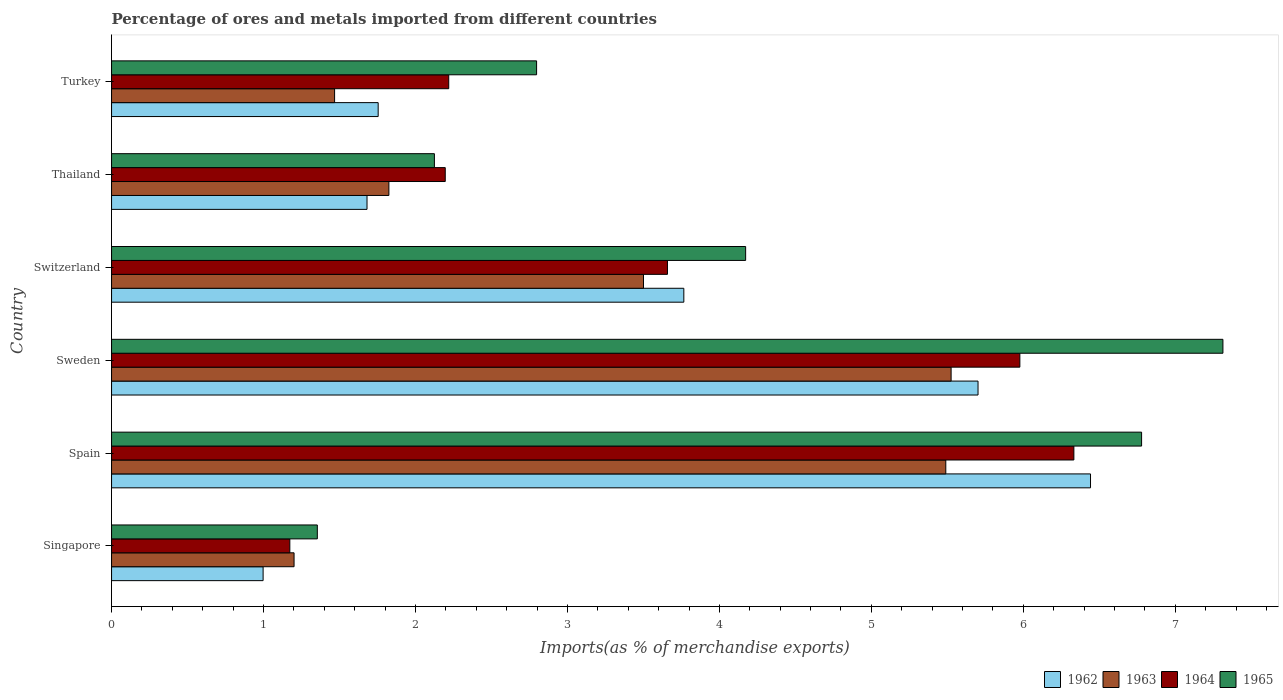Are the number of bars per tick equal to the number of legend labels?
Make the answer very short. Yes. What is the label of the 2nd group of bars from the top?
Offer a terse response. Thailand. In how many cases, is the number of bars for a given country not equal to the number of legend labels?
Provide a short and direct response. 0. What is the percentage of imports to different countries in 1963 in Sweden?
Provide a succinct answer. 5.52. Across all countries, what is the maximum percentage of imports to different countries in 1965?
Make the answer very short. 7.31. Across all countries, what is the minimum percentage of imports to different countries in 1962?
Make the answer very short. 1. In which country was the percentage of imports to different countries in 1963 maximum?
Ensure brevity in your answer.  Sweden. In which country was the percentage of imports to different countries in 1964 minimum?
Keep it short and to the point. Singapore. What is the total percentage of imports to different countries in 1963 in the graph?
Provide a short and direct response. 19.01. What is the difference between the percentage of imports to different countries in 1963 in Singapore and that in Turkey?
Give a very brief answer. -0.27. What is the difference between the percentage of imports to different countries in 1963 in Switzerland and the percentage of imports to different countries in 1962 in Spain?
Provide a short and direct response. -2.94. What is the average percentage of imports to different countries in 1965 per country?
Provide a short and direct response. 4.09. What is the difference between the percentage of imports to different countries in 1964 and percentage of imports to different countries in 1963 in Singapore?
Your answer should be compact. -0.03. What is the ratio of the percentage of imports to different countries in 1965 in Thailand to that in Turkey?
Give a very brief answer. 0.76. Is the percentage of imports to different countries in 1964 in Switzerland less than that in Thailand?
Keep it short and to the point. No. Is the difference between the percentage of imports to different countries in 1964 in Sweden and Thailand greater than the difference between the percentage of imports to different countries in 1963 in Sweden and Thailand?
Provide a short and direct response. Yes. What is the difference between the highest and the second highest percentage of imports to different countries in 1962?
Your response must be concise. 0.74. What is the difference between the highest and the lowest percentage of imports to different countries in 1962?
Ensure brevity in your answer.  5.45. In how many countries, is the percentage of imports to different countries in 1964 greater than the average percentage of imports to different countries in 1964 taken over all countries?
Make the answer very short. 3. Is the sum of the percentage of imports to different countries in 1964 in Singapore and Spain greater than the maximum percentage of imports to different countries in 1962 across all countries?
Your answer should be very brief. Yes. Is it the case that in every country, the sum of the percentage of imports to different countries in 1964 and percentage of imports to different countries in 1963 is greater than the sum of percentage of imports to different countries in 1962 and percentage of imports to different countries in 1965?
Ensure brevity in your answer.  No. What does the 1st bar from the top in Spain represents?
Your response must be concise. 1965. What does the 4th bar from the bottom in Turkey represents?
Your answer should be compact. 1965. How many bars are there?
Provide a short and direct response. 24. How many countries are there in the graph?
Provide a succinct answer. 6. What is the difference between two consecutive major ticks on the X-axis?
Offer a terse response. 1. Does the graph contain any zero values?
Offer a very short reply. No. Where does the legend appear in the graph?
Keep it short and to the point. Bottom right. How are the legend labels stacked?
Your answer should be compact. Horizontal. What is the title of the graph?
Your answer should be very brief. Percentage of ores and metals imported from different countries. Does "1972" appear as one of the legend labels in the graph?
Offer a very short reply. No. What is the label or title of the X-axis?
Your answer should be compact. Imports(as % of merchandise exports). What is the Imports(as % of merchandise exports) in 1962 in Singapore?
Offer a very short reply. 1. What is the Imports(as % of merchandise exports) in 1963 in Singapore?
Make the answer very short. 1.2. What is the Imports(as % of merchandise exports) in 1964 in Singapore?
Provide a succinct answer. 1.17. What is the Imports(as % of merchandise exports) in 1965 in Singapore?
Your answer should be very brief. 1.35. What is the Imports(as % of merchandise exports) in 1962 in Spain?
Keep it short and to the point. 6.44. What is the Imports(as % of merchandise exports) in 1963 in Spain?
Ensure brevity in your answer.  5.49. What is the Imports(as % of merchandise exports) in 1964 in Spain?
Your response must be concise. 6.33. What is the Imports(as % of merchandise exports) in 1965 in Spain?
Your answer should be very brief. 6.78. What is the Imports(as % of merchandise exports) in 1962 in Sweden?
Give a very brief answer. 5.7. What is the Imports(as % of merchandise exports) of 1963 in Sweden?
Your answer should be very brief. 5.52. What is the Imports(as % of merchandise exports) of 1964 in Sweden?
Make the answer very short. 5.98. What is the Imports(as % of merchandise exports) in 1965 in Sweden?
Ensure brevity in your answer.  7.31. What is the Imports(as % of merchandise exports) in 1962 in Switzerland?
Keep it short and to the point. 3.77. What is the Imports(as % of merchandise exports) of 1963 in Switzerland?
Your answer should be compact. 3.5. What is the Imports(as % of merchandise exports) of 1964 in Switzerland?
Offer a terse response. 3.66. What is the Imports(as % of merchandise exports) of 1965 in Switzerland?
Your response must be concise. 4.17. What is the Imports(as % of merchandise exports) of 1962 in Thailand?
Keep it short and to the point. 1.68. What is the Imports(as % of merchandise exports) in 1963 in Thailand?
Your answer should be compact. 1.83. What is the Imports(as % of merchandise exports) of 1964 in Thailand?
Make the answer very short. 2.2. What is the Imports(as % of merchandise exports) in 1965 in Thailand?
Your answer should be compact. 2.12. What is the Imports(as % of merchandise exports) in 1962 in Turkey?
Provide a short and direct response. 1.75. What is the Imports(as % of merchandise exports) of 1963 in Turkey?
Ensure brevity in your answer.  1.47. What is the Imports(as % of merchandise exports) of 1964 in Turkey?
Keep it short and to the point. 2.22. What is the Imports(as % of merchandise exports) of 1965 in Turkey?
Offer a terse response. 2.8. Across all countries, what is the maximum Imports(as % of merchandise exports) of 1962?
Provide a short and direct response. 6.44. Across all countries, what is the maximum Imports(as % of merchandise exports) in 1963?
Your response must be concise. 5.52. Across all countries, what is the maximum Imports(as % of merchandise exports) in 1964?
Your answer should be compact. 6.33. Across all countries, what is the maximum Imports(as % of merchandise exports) in 1965?
Provide a short and direct response. 7.31. Across all countries, what is the minimum Imports(as % of merchandise exports) in 1962?
Give a very brief answer. 1. Across all countries, what is the minimum Imports(as % of merchandise exports) in 1963?
Keep it short and to the point. 1.2. Across all countries, what is the minimum Imports(as % of merchandise exports) of 1964?
Your answer should be compact. 1.17. Across all countries, what is the minimum Imports(as % of merchandise exports) in 1965?
Keep it short and to the point. 1.35. What is the total Imports(as % of merchandise exports) of 1962 in the graph?
Offer a very short reply. 20.34. What is the total Imports(as % of merchandise exports) of 1963 in the graph?
Provide a succinct answer. 19.01. What is the total Imports(as % of merchandise exports) of 1964 in the graph?
Your answer should be compact. 21.56. What is the total Imports(as % of merchandise exports) of 1965 in the graph?
Ensure brevity in your answer.  24.54. What is the difference between the Imports(as % of merchandise exports) in 1962 in Singapore and that in Spain?
Offer a very short reply. -5.45. What is the difference between the Imports(as % of merchandise exports) of 1963 in Singapore and that in Spain?
Offer a very short reply. -4.29. What is the difference between the Imports(as % of merchandise exports) in 1964 in Singapore and that in Spain?
Make the answer very short. -5.16. What is the difference between the Imports(as % of merchandise exports) of 1965 in Singapore and that in Spain?
Your response must be concise. -5.42. What is the difference between the Imports(as % of merchandise exports) in 1962 in Singapore and that in Sweden?
Offer a terse response. -4.7. What is the difference between the Imports(as % of merchandise exports) of 1963 in Singapore and that in Sweden?
Give a very brief answer. -4.32. What is the difference between the Imports(as % of merchandise exports) in 1964 in Singapore and that in Sweden?
Keep it short and to the point. -4.8. What is the difference between the Imports(as % of merchandise exports) in 1965 in Singapore and that in Sweden?
Provide a succinct answer. -5.96. What is the difference between the Imports(as % of merchandise exports) of 1962 in Singapore and that in Switzerland?
Offer a very short reply. -2.77. What is the difference between the Imports(as % of merchandise exports) of 1963 in Singapore and that in Switzerland?
Offer a very short reply. -2.3. What is the difference between the Imports(as % of merchandise exports) in 1964 in Singapore and that in Switzerland?
Your answer should be compact. -2.49. What is the difference between the Imports(as % of merchandise exports) of 1965 in Singapore and that in Switzerland?
Your response must be concise. -2.82. What is the difference between the Imports(as % of merchandise exports) of 1962 in Singapore and that in Thailand?
Your response must be concise. -0.68. What is the difference between the Imports(as % of merchandise exports) in 1963 in Singapore and that in Thailand?
Provide a short and direct response. -0.62. What is the difference between the Imports(as % of merchandise exports) of 1964 in Singapore and that in Thailand?
Your response must be concise. -1.02. What is the difference between the Imports(as % of merchandise exports) in 1965 in Singapore and that in Thailand?
Your answer should be very brief. -0.77. What is the difference between the Imports(as % of merchandise exports) in 1962 in Singapore and that in Turkey?
Provide a succinct answer. -0.76. What is the difference between the Imports(as % of merchandise exports) of 1963 in Singapore and that in Turkey?
Provide a short and direct response. -0.27. What is the difference between the Imports(as % of merchandise exports) of 1964 in Singapore and that in Turkey?
Provide a short and direct response. -1.05. What is the difference between the Imports(as % of merchandise exports) of 1965 in Singapore and that in Turkey?
Ensure brevity in your answer.  -1.44. What is the difference between the Imports(as % of merchandise exports) in 1962 in Spain and that in Sweden?
Your answer should be compact. 0.74. What is the difference between the Imports(as % of merchandise exports) of 1963 in Spain and that in Sweden?
Offer a very short reply. -0.04. What is the difference between the Imports(as % of merchandise exports) in 1964 in Spain and that in Sweden?
Offer a very short reply. 0.36. What is the difference between the Imports(as % of merchandise exports) in 1965 in Spain and that in Sweden?
Ensure brevity in your answer.  -0.54. What is the difference between the Imports(as % of merchandise exports) in 1962 in Spain and that in Switzerland?
Make the answer very short. 2.68. What is the difference between the Imports(as % of merchandise exports) of 1963 in Spain and that in Switzerland?
Give a very brief answer. 1.99. What is the difference between the Imports(as % of merchandise exports) of 1964 in Spain and that in Switzerland?
Keep it short and to the point. 2.67. What is the difference between the Imports(as % of merchandise exports) of 1965 in Spain and that in Switzerland?
Your answer should be compact. 2.61. What is the difference between the Imports(as % of merchandise exports) in 1962 in Spain and that in Thailand?
Keep it short and to the point. 4.76. What is the difference between the Imports(as % of merchandise exports) of 1963 in Spain and that in Thailand?
Keep it short and to the point. 3.66. What is the difference between the Imports(as % of merchandise exports) of 1964 in Spain and that in Thailand?
Give a very brief answer. 4.14. What is the difference between the Imports(as % of merchandise exports) in 1965 in Spain and that in Thailand?
Offer a terse response. 4.65. What is the difference between the Imports(as % of merchandise exports) of 1962 in Spain and that in Turkey?
Provide a succinct answer. 4.69. What is the difference between the Imports(as % of merchandise exports) of 1963 in Spain and that in Turkey?
Offer a very short reply. 4.02. What is the difference between the Imports(as % of merchandise exports) in 1964 in Spain and that in Turkey?
Offer a very short reply. 4.11. What is the difference between the Imports(as % of merchandise exports) of 1965 in Spain and that in Turkey?
Ensure brevity in your answer.  3.98. What is the difference between the Imports(as % of merchandise exports) in 1962 in Sweden and that in Switzerland?
Give a very brief answer. 1.94. What is the difference between the Imports(as % of merchandise exports) in 1963 in Sweden and that in Switzerland?
Your answer should be very brief. 2.02. What is the difference between the Imports(as % of merchandise exports) in 1964 in Sweden and that in Switzerland?
Provide a succinct answer. 2.32. What is the difference between the Imports(as % of merchandise exports) in 1965 in Sweden and that in Switzerland?
Offer a very short reply. 3.14. What is the difference between the Imports(as % of merchandise exports) in 1962 in Sweden and that in Thailand?
Keep it short and to the point. 4.02. What is the difference between the Imports(as % of merchandise exports) of 1963 in Sweden and that in Thailand?
Ensure brevity in your answer.  3.7. What is the difference between the Imports(as % of merchandise exports) of 1964 in Sweden and that in Thailand?
Ensure brevity in your answer.  3.78. What is the difference between the Imports(as % of merchandise exports) in 1965 in Sweden and that in Thailand?
Make the answer very short. 5.19. What is the difference between the Imports(as % of merchandise exports) in 1962 in Sweden and that in Turkey?
Make the answer very short. 3.95. What is the difference between the Imports(as % of merchandise exports) of 1963 in Sweden and that in Turkey?
Your response must be concise. 4.06. What is the difference between the Imports(as % of merchandise exports) in 1964 in Sweden and that in Turkey?
Provide a short and direct response. 3.76. What is the difference between the Imports(as % of merchandise exports) of 1965 in Sweden and that in Turkey?
Your answer should be compact. 4.52. What is the difference between the Imports(as % of merchandise exports) in 1962 in Switzerland and that in Thailand?
Your answer should be compact. 2.08. What is the difference between the Imports(as % of merchandise exports) of 1963 in Switzerland and that in Thailand?
Make the answer very short. 1.68. What is the difference between the Imports(as % of merchandise exports) in 1964 in Switzerland and that in Thailand?
Offer a terse response. 1.46. What is the difference between the Imports(as % of merchandise exports) in 1965 in Switzerland and that in Thailand?
Offer a terse response. 2.05. What is the difference between the Imports(as % of merchandise exports) in 1962 in Switzerland and that in Turkey?
Offer a very short reply. 2.01. What is the difference between the Imports(as % of merchandise exports) of 1963 in Switzerland and that in Turkey?
Your answer should be compact. 2.03. What is the difference between the Imports(as % of merchandise exports) in 1964 in Switzerland and that in Turkey?
Your answer should be very brief. 1.44. What is the difference between the Imports(as % of merchandise exports) of 1965 in Switzerland and that in Turkey?
Keep it short and to the point. 1.38. What is the difference between the Imports(as % of merchandise exports) of 1962 in Thailand and that in Turkey?
Offer a very short reply. -0.07. What is the difference between the Imports(as % of merchandise exports) of 1963 in Thailand and that in Turkey?
Offer a terse response. 0.36. What is the difference between the Imports(as % of merchandise exports) in 1964 in Thailand and that in Turkey?
Give a very brief answer. -0.02. What is the difference between the Imports(as % of merchandise exports) of 1965 in Thailand and that in Turkey?
Make the answer very short. -0.67. What is the difference between the Imports(as % of merchandise exports) in 1962 in Singapore and the Imports(as % of merchandise exports) in 1963 in Spain?
Keep it short and to the point. -4.49. What is the difference between the Imports(as % of merchandise exports) in 1962 in Singapore and the Imports(as % of merchandise exports) in 1964 in Spain?
Your response must be concise. -5.34. What is the difference between the Imports(as % of merchandise exports) in 1962 in Singapore and the Imports(as % of merchandise exports) in 1965 in Spain?
Offer a terse response. -5.78. What is the difference between the Imports(as % of merchandise exports) of 1963 in Singapore and the Imports(as % of merchandise exports) of 1964 in Spain?
Offer a terse response. -5.13. What is the difference between the Imports(as % of merchandise exports) of 1963 in Singapore and the Imports(as % of merchandise exports) of 1965 in Spain?
Provide a short and direct response. -5.58. What is the difference between the Imports(as % of merchandise exports) of 1964 in Singapore and the Imports(as % of merchandise exports) of 1965 in Spain?
Make the answer very short. -5.61. What is the difference between the Imports(as % of merchandise exports) in 1962 in Singapore and the Imports(as % of merchandise exports) in 1963 in Sweden?
Offer a terse response. -4.53. What is the difference between the Imports(as % of merchandise exports) of 1962 in Singapore and the Imports(as % of merchandise exports) of 1964 in Sweden?
Make the answer very short. -4.98. What is the difference between the Imports(as % of merchandise exports) in 1962 in Singapore and the Imports(as % of merchandise exports) in 1965 in Sweden?
Your answer should be compact. -6.32. What is the difference between the Imports(as % of merchandise exports) in 1963 in Singapore and the Imports(as % of merchandise exports) in 1964 in Sweden?
Provide a succinct answer. -4.78. What is the difference between the Imports(as % of merchandise exports) in 1963 in Singapore and the Imports(as % of merchandise exports) in 1965 in Sweden?
Your answer should be compact. -6.11. What is the difference between the Imports(as % of merchandise exports) of 1964 in Singapore and the Imports(as % of merchandise exports) of 1965 in Sweden?
Provide a succinct answer. -6.14. What is the difference between the Imports(as % of merchandise exports) of 1962 in Singapore and the Imports(as % of merchandise exports) of 1963 in Switzerland?
Keep it short and to the point. -2.5. What is the difference between the Imports(as % of merchandise exports) in 1962 in Singapore and the Imports(as % of merchandise exports) in 1964 in Switzerland?
Your answer should be compact. -2.66. What is the difference between the Imports(as % of merchandise exports) in 1962 in Singapore and the Imports(as % of merchandise exports) in 1965 in Switzerland?
Make the answer very short. -3.18. What is the difference between the Imports(as % of merchandise exports) in 1963 in Singapore and the Imports(as % of merchandise exports) in 1964 in Switzerland?
Provide a succinct answer. -2.46. What is the difference between the Imports(as % of merchandise exports) in 1963 in Singapore and the Imports(as % of merchandise exports) in 1965 in Switzerland?
Provide a succinct answer. -2.97. What is the difference between the Imports(as % of merchandise exports) of 1964 in Singapore and the Imports(as % of merchandise exports) of 1965 in Switzerland?
Your response must be concise. -3. What is the difference between the Imports(as % of merchandise exports) of 1962 in Singapore and the Imports(as % of merchandise exports) of 1963 in Thailand?
Your response must be concise. -0.83. What is the difference between the Imports(as % of merchandise exports) of 1962 in Singapore and the Imports(as % of merchandise exports) of 1964 in Thailand?
Give a very brief answer. -1.2. What is the difference between the Imports(as % of merchandise exports) in 1962 in Singapore and the Imports(as % of merchandise exports) in 1965 in Thailand?
Your answer should be very brief. -1.13. What is the difference between the Imports(as % of merchandise exports) in 1963 in Singapore and the Imports(as % of merchandise exports) in 1964 in Thailand?
Offer a very short reply. -0.99. What is the difference between the Imports(as % of merchandise exports) in 1963 in Singapore and the Imports(as % of merchandise exports) in 1965 in Thailand?
Your answer should be very brief. -0.92. What is the difference between the Imports(as % of merchandise exports) of 1964 in Singapore and the Imports(as % of merchandise exports) of 1965 in Thailand?
Offer a very short reply. -0.95. What is the difference between the Imports(as % of merchandise exports) of 1962 in Singapore and the Imports(as % of merchandise exports) of 1963 in Turkey?
Provide a succinct answer. -0.47. What is the difference between the Imports(as % of merchandise exports) of 1962 in Singapore and the Imports(as % of merchandise exports) of 1964 in Turkey?
Ensure brevity in your answer.  -1.22. What is the difference between the Imports(as % of merchandise exports) in 1962 in Singapore and the Imports(as % of merchandise exports) in 1965 in Turkey?
Provide a short and direct response. -1.8. What is the difference between the Imports(as % of merchandise exports) of 1963 in Singapore and the Imports(as % of merchandise exports) of 1964 in Turkey?
Offer a terse response. -1.02. What is the difference between the Imports(as % of merchandise exports) of 1963 in Singapore and the Imports(as % of merchandise exports) of 1965 in Turkey?
Provide a succinct answer. -1.6. What is the difference between the Imports(as % of merchandise exports) of 1964 in Singapore and the Imports(as % of merchandise exports) of 1965 in Turkey?
Offer a very short reply. -1.62. What is the difference between the Imports(as % of merchandise exports) of 1962 in Spain and the Imports(as % of merchandise exports) of 1963 in Sweden?
Provide a short and direct response. 0.92. What is the difference between the Imports(as % of merchandise exports) of 1962 in Spain and the Imports(as % of merchandise exports) of 1964 in Sweden?
Provide a succinct answer. 0.47. What is the difference between the Imports(as % of merchandise exports) of 1962 in Spain and the Imports(as % of merchandise exports) of 1965 in Sweden?
Keep it short and to the point. -0.87. What is the difference between the Imports(as % of merchandise exports) of 1963 in Spain and the Imports(as % of merchandise exports) of 1964 in Sweden?
Keep it short and to the point. -0.49. What is the difference between the Imports(as % of merchandise exports) in 1963 in Spain and the Imports(as % of merchandise exports) in 1965 in Sweden?
Your answer should be very brief. -1.82. What is the difference between the Imports(as % of merchandise exports) of 1964 in Spain and the Imports(as % of merchandise exports) of 1965 in Sweden?
Keep it short and to the point. -0.98. What is the difference between the Imports(as % of merchandise exports) of 1962 in Spain and the Imports(as % of merchandise exports) of 1963 in Switzerland?
Your response must be concise. 2.94. What is the difference between the Imports(as % of merchandise exports) of 1962 in Spain and the Imports(as % of merchandise exports) of 1964 in Switzerland?
Keep it short and to the point. 2.78. What is the difference between the Imports(as % of merchandise exports) of 1962 in Spain and the Imports(as % of merchandise exports) of 1965 in Switzerland?
Make the answer very short. 2.27. What is the difference between the Imports(as % of merchandise exports) in 1963 in Spain and the Imports(as % of merchandise exports) in 1964 in Switzerland?
Provide a succinct answer. 1.83. What is the difference between the Imports(as % of merchandise exports) of 1963 in Spain and the Imports(as % of merchandise exports) of 1965 in Switzerland?
Make the answer very short. 1.32. What is the difference between the Imports(as % of merchandise exports) of 1964 in Spain and the Imports(as % of merchandise exports) of 1965 in Switzerland?
Make the answer very short. 2.16. What is the difference between the Imports(as % of merchandise exports) of 1962 in Spain and the Imports(as % of merchandise exports) of 1963 in Thailand?
Offer a very short reply. 4.62. What is the difference between the Imports(as % of merchandise exports) of 1962 in Spain and the Imports(as % of merchandise exports) of 1964 in Thailand?
Your response must be concise. 4.25. What is the difference between the Imports(as % of merchandise exports) of 1962 in Spain and the Imports(as % of merchandise exports) of 1965 in Thailand?
Offer a very short reply. 4.32. What is the difference between the Imports(as % of merchandise exports) in 1963 in Spain and the Imports(as % of merchandise exports) in 1964 in Thailand?
Offer a terse response. 3.29. What is the difference between the Imports(as % of merchandise exports) in 1963 in Spain and the Imports(as % of merchandise exports) in 1965 in Thailand?
Keep it short and to the point. 3.37. What is the difference between the Imports(as % of merchandise exports) of 1964 in Spain and the Imports(as % of merchandise exports) of 1965 in Thailand?
Offer a terse response. 4.21. What is the difference between the Imports(as % of merchandise exports) in 1962 in Spain and the Imports(as % of merchandise exports) in 1963 in Turkey?
Provide a short and direct response. 4.97. What is the difference between the Imports(as % of merchandise exports) in 1962 in Spain and the Imports(as % of merchandise exports) in 1964 in Turkey?
Offer a terse response. 4.22. What is the difference between the Imports(as % of merchandise exports) in 1962 in Spain and the Imports(as % of merchandise exports) in 1965 in Turkey?
Provide a succinct answer. 3.65. What is the difference between the Imports(as % of merchandise exports) of 1963 in Spain and the Imports(as % of merchandise exports) of 1964 in Turkey?
Provide a succinct answer. 3.27. What is the difference between the Imports(as % of merchandise exports) in 1963 in Spain and the Imports(as % of merchandise exports) in 1965 in Turkey?
Offer a terse response. 2.69. What is the difference between the Imports(as % of merchandise exports) of 1964 in Spain and the Imports(as % of merchandise exports) of 1965 in Turkey?
Your response must be concise. 3.54. What is the difference between the Imports(as % of merchandise exports) in 1962 in Sweden and the Imports(as % of merchandise exports) in 1963 in Switzerland?
Make the answer very short. 2.2. What is the difference between the Imports(as % of merchandise exports) in 1962 in Sweden and the Imports(as % of merchandise exports) in 1964 in Switzerland?
Give a very brief answer. 2.04. What is the difference between the Imports(as % of merchandise exports) of 1962 in Sweden and the Imports(as % of merchandise exports) of 1965 in Switzerland?
Ensure brevity in your answer.  1.53. What is the difference between the Imports(as % of merchandise exports) in 1963 in Sweden and the Imports(as % of merchandise exports) in 1964 in Switzerland?
Offer a terse response. 1.87. What is the difference between the Imports(as % of merchandise exports) of 1963 in Sweden and the Imports(as % of merchandise exports) of 1965 in Switzerland?
Offer a terse response. 1.35. What is the difference between the Imports(as % of merchandise exports) of 1964 in Sweden and the Imports(as % of merchandise exports) of 1965 in Switzerland?
Provide a short and direct response. 1.8. What is the difference between the Imports(as % of merchandise exports) of 1962 in Sweden and the Imports(as % of merchandise exports) of 1963 in Thailand?
Provide a succinct answer. 3.88. What is the difference between the Imports(as % of merchandise exports) in 1962 in Sweden and the Imports(as % of merchandise exports) in 1964 in Thailand?
Ensure brevity in your answer.  3.51. What is the difference between the Imports(as % of merchandise exports) in 1962 in Sweden and the Imports(as % of merchandise exports) in 1965 in Thailand?
Your answer should be compact. 3.58. What is the difference between the Imports(as % of merchandise exports) of 1963 in Sweden and the Imports(as % of merchandise exports) of 1964 in Thailand?
Make the answer very short. 3.33. What is the difference between the Imports(as % of merchandise exports) of 1963 in Sweden and the Imports(as % of merchandise exports) of 1965 in Thailand?
Offer a terse response. 3.4. What is the difference between the Imports(as % of merchandise exports) of 1964 in Sweden and the Imports(as % of merchandise exports) of 1965 in Thailand?
Provide a short and direct response. 3.85. What is the difference between the Imports(as % of merchandise exports) in 1962 in Sweden and the Imports(as % of merchandise exports) in 1963 in Turkey?
Offer a very short reply. 4.23. What is the difference between the Imports(as % of merchandise exports) in 1962 in Sweden and the Imports(as % of merchandise exports) in 1964 in Turkey?
Keep it short and to the point. 3.48. What is the difference between the Imports(as % of merchandise exports) in 1962 in Sweden and the Imports(as % of merchandise exports) in 1965 in Turkey?
Make the answer very short. 2.9. What is the difference between the Imports(as % of merchandise exports) of 1963 in Sweden and the Imports(as % of merchandise exports) of 1964 in Turkey?
Ensure brevity in your answer.  3.31. What is the difference between the Imports(as % of merchandise exports) of 1963 in Sweden and the Imports(as % of merchandise exports) of 1965 in Turkey?
Provide a short and direct response. 2.73. What is the difference between the Imports(as % of merchandise exports) in 1964 in Sweden and the Imports(as % of merchandise exports) in 1965 in Turkey?
Provide a succinct answer. 3.18. What is the difference between the Imports(as % of merchandise exports) of 1962 in Switzerland and the Imports(as % of merchandise exports) of 1963 in Thailand?
Provide a short and direct response. 1.94. What is the difference between the Imports(as % of merchandise exports) in 1962 in Switzerland and the Imports(as % of merchandise exports) in 1964 in Thailand?
Your response must be concise. 1.57. What is the difference between the Imports(as % of merchandise exports) in 1962 in Switzerland and the Imports(as % of merchandise exports) in 1965 in Thailand?
Provide a short and direct response. 1.64. What is the difference between the Imports(as % of merchandise exports) of 1963 in Switzerland and the Imports(as % of merchandise exports) of 1964 in Thailand?
Keep it short and to the point. 1.3. What is the difference between the Imports(as % of merchandise exports) of 1963 in Switzerland and the Imports(as % of merchandise exports) of 1965 in Thailand?
Keep it short and to the point. 1.38. What is the difference between the Imports(as % of merchandise exports) of 1964 in Switzerland and the Imports(as % of merchandise exports) of 1965 in Thailand?
Your response must be concise. 1.53. What is the difference between the Imports(as % of merchandise exports) of 1962 in Switzerland and the Imports(as % of merchandise exports) of 1963 in Turkey?
Give a very brief answer. 2.3. What is the difference between the Imports(as % of merchandise exports) in 1962 in Switzerland and the Imports(as % of merchandise exports) in 1964 in Turkey?
Keep it short and to the point. 1.55. What is the difference between the Imports(as % of merchandise exports) in 1962 in Switzerland and the Imports(as % of merchandise exports) in 1965 in Turkey?
Offer a terse response. 0.97. What is the difference between the Imports(as % of merchandise exports) in 1963 in Switzerland and the Imports(as % of merchandise exports) in 1964 in Turkey?
Your answer should be very brief. 1.28. What is the difference between the Imports(as % of merchandise exports) of 1963 in Switzerland and the Imports(as % of merchandise exports) of 1965 in Turkey?
Offer a very short reply. 0.7. What is the difference between the Imports(as % of merchandise exports) of 1964 in Switzerland and the Imports(as % of merchandise exports) of 1965 in Turkey?
Keep it short and to the point. 0.86. What is the difference between the Imports(as % of merchandise exports) of 1962 in Thailand and the Imports(as % of merchandise exports) of 1963 in Turkey?
Provide a short and direct response. 0.21. What is the difference between the Imports(as % of merchandise exports) in 1962 in Thailand and the Imports(as % of merchandise exports) in 1964 in Turkey?
Your answer should be compact. -0.54. What is the difference between the Imports(as % of merchandise exports) in 1962 in Thailand and the Imports(as % of merchandise exports) in 1965 in Turkey?
Give a very brief answer. -1.12. What is the difference between the Imports(as % of merchandise exports) of 1963 in Thailand and the Imports(as % of merchandise exports) of 1964 in Turkey?
Your response must be concise. -0.39. What is the difference between the Imports(as % of merchandise exports) in 1963 in Thailand and the Imports(as % of merchandise exports) in 1965 in Turkey?
Your response must be concise. -0.97. What is the difference between the Imports(as % of merchandise exports) of 1964 in Thailand and the Imports(as % of merchandise exports) of 1965 in Turkey?
Your response must be concise. -0.6. What is the average Imports(as % of merchandise exports) in 1962 per country?
Your answer should be compact. 3.39. What is the average Imports(as % of merchandise exports) of 1963 per country?
Provide a short and direct response. 3.17. What is the average Imports(as % of merchandise exports) in 1964 per country?
Offer a very short reply. 3.59. What is the average Imports(as % of merchandise exports) of 1965 per country?
Keep it short and to the point. 4.09. What is the difference between the Imports(as % of merchandise exports) in 1962 and Imports(as % of merchandise exports) in 1963 in Singapore?
Make the answer very short. -0.2. What is the difference between the Imports(as % of merchandise exports) of 1962 and Imports(as % of merchandise exports) of 1964 in Singapore?
Provide a succinct answer. -0.18. What is the difference between the Imports(as % of merchandise exports) in 1962 and Imports(as % of merchandise exports) in 1965 in Singapore?
Offer a very short reply. -0.36. What is the difference between the Imports(as % of merchandise exports) of 1963 and Imports(as % of merchandise exports) of 1964 in Singapore?
Your answer should be very brief. 0.03. What is the difference between the Imports(as % of merchandise exports) in 1963 and Imports(as % of merchandise exports) in 1965 in Singapore?
Give a very brief answer. -0.15. What is the difference between the Imports(as % of merchandise exports) in 1964 and Imports(as % of merchandise exports) in 1965 in Singapore?
Your answer should be compact. -0.18. What is the difference between the Imports(as % of merchandise exports) of 1962 and Imports(as % of merchandise exports) of 1964 in Spain?
Ensure brevity in your answer.  0.11. What is the difference between the Imports(as % of merchandise exports) in 1962 and Imports(as % of merchandise exports) in 1965 in Spain?
Provide a short and direct response. -0.34. What is the difference between the Imports(as % of merchandise exports) in 1963 and Imports(as % of merchandise exports) in 1964 in Spain?
Offer a terse response. -0.84. What is the difference between the Imports(as % of merchandise exports) of 1963 and Imports(as % of merchandise exports) of 1965 in Spain?
Your response must be concise. -1.29. What is the difference between the Imports(as % of merchandise exports) in 1964 and Imports(as % of merchandise exports) in 1965 in Spain?
Make the answer very short. -0.45. What is the difference between the Imports(as % of merchandise exports) of 1962 and Imports(as % of merchandise exports) of 1963 in Sweden?
Your answer should be very brief. 0.18. What is the difference between the Imports(as % of merchandise exports) in 1962 and Imports(as % of merchandise exports) in 1964 in Sweden?
Ensure brevity in your answer.  -0.28. What is the difference between the Imports(as % of merchandise exports) in 1962 and Imports(as % of merchandise exports) in 1965 in Sweden?
Provide a succinct answer. -1.61. What is the difference between the Imports(as % of merchandise exports) of 1963 and Imports(as % of merchandise exports) of 1964 in Sweden?
Your answer should be very brief. -0.45. What is the difference between the Imports(as % of merchandise exports) of 1963 and Imports(as % of merchandise exports) of 1965 in Sweden?
Offer a terse response. -1.79. What is the difference between the Imports(as % of merchandise exports) in 1964 and Imports(as % of merchandise exports) in 1965 in Sweden?
Ensure brevity in your answer.  -1.34. What is the difference between the Imports(as % of merchandise exports) in 1962 and Imports(as % of merchandise exports) in 1963 in Switzerland?
Give a very brief answer. 0.27. What is the difference between the Imports(as % of merchandise exports) in 1962 and Imports(as % of merchandise exports) in 1964 in Switzerland?
Offer a terse response. 0.11. What is the difference between the Imports(as % of merchandise exports) in 1962 and Imports(as % of merchandise exports) in 1965 in Switzerland?
Give a very brief answer. -0.41. What is the difference between the Imports(as % of merchandise exports) in 1963 and Imports(as % of merchandise exports) in 1964 in Switzerland?
Your answer should be very brief. -0.16. What is the difference between the Imports(as % of merchandise exports) of 1963 and Imports(as % of merchandise exports) of 1965 in Switzerland?
Offer a terse response. -0.67. What is the difference between the Imports(as % of merchandise exports) of 1964 and Imports(as % of merchandise exports) of 1965 in Switzerland?
Provide a succinct answer. -0.51. What is the difference between the Imports(as % of merchandise exports) in 1962 and Imports(as % of merchandise exports) in 1963 in Thailand?
Offer a very short reply. -0.14. What is the difference between the Imports(as % of merchandise exports) of 1962 and Imports(as % of merchandise exports) of 1964 in Thailand?
Your answer should be very brief. -0.51. What is the difference between the Imports(as % of merchandise exports) in 1962 and Imports(as % of merchandise exports) in 1965 in Thailand?
Give a very brief answer. -0.44. What is the difference between the Imports(as % of merchandise exports) in 1963 and Imports(as % of merchandise exports) in 1964 in Thailand?
Your response must be concise. -0.37. What is the difference between the Imports(as % of merchandise exports) of 1963 and Imports(as % of merchandise exports) of 1965 in Thailand?
Your answer should be very brief. -0.3. What is the difference between the Imports(as % of merchandise exports) of 1964 and Imports(as % of merchandise exports) of 1965 in Thailand?
Offer a very short reply. 0.07. What is the difference between the Imports(as % of merchandise exports) in 1962 and Imports(as % of merchandise exports) in 1963 in Turkey?
Your answer should be very brief. 0.29. What is the difference between the Imports(as % of merchandise exports) of 1962 and Imports(as % of merchandise exports) of 1964 in Turkey?
Keep it short and to the point. -0.46. What is the difference between the Imports(as % of merchandise exports) of 1962 and Imports(as % of merchandise exports) of 1965 in Turkey?
Ensure brevity in your answer.  -1.04. What is the difference between the Imports(as % of merchandise exports) in 1963 and Imports(as % of merchandise exports) in 1964 in Turkey?
Your answer should be very brief. -0.75. What is the difference between the Imports(as % of merchandise exports) in 1963 and Imports(as % of merchandise exports) in 1965 in Turkey?
Provide a short and direct response. -1.33. What is the difference between the Imports(as % of merchandise exports) of 1964 and Imports(as % of merchandise exports) of 1965 in Turkey?
Ensure brevity in your answer.  -0.58. What is the ratio of the Imports(as % of merchandise exports) of 1962 in Singapore to that in Spain?
Give a very brief answer. 0.15. What is the ratio of the Imports(as % of merchandise exports) in 1963 in Singapore to that in Spain?
Make the answer very short. 0.22. What is the ratio of the Imports(as % of merchandise exports) in 1964 in Singapore to that in Spain?
Your response must be concise. 0.19. What is the ratio of the Imports(as % of merchandise exports) of 1965 in Singapore to that in Spain?
Make the answer very short. 0.2. What is the ratio of the Imports(as % of merchandise exports) of 1962 in Singapore to that in Sweden?
Your answer should be compact. 0.17. What is the ratio of the Imports(as % of merchandise exports) of 1963 in Singapore to that in Sweden?
Ensure brevity in your answer.  0.22. What is the ratio of the Imports(as % of merchandise exports) of 1964 in Singapore to that in Sweden?
Offer a terse response. 0.2. What is the ratio of the Imports(as % of merchandise exports) of 1965 in Singapore to that in Sweden?
Offer a terse response. 0.19. What is the ratio of the Imports(as % of merchandise exports) of 1962 in Singapore to that in Switzerland?
Provide a short and direct response. 0.26. What is the ratio of the Imports(as % of merchandise exports) in 1963 in Singapore to that in Switzerland?
Your answer should be very brief. 0.34. What is the ratio of the Imports(as % of merchandise exports) of 1964 in Singapore to that in Switzerland?
Provide a short and direct response. 0.32. What is the ratio of the Imports(as % of merchandise exports) in 1965 in Singapore to that in Switzerland?
Offer a terse response. 0.32. What is the ratio of the Imports(as % of merchandise exports) of 1962 in Singapore to that in Thailand?
Offer a terse response. 0.59. What is the ratio of the Imports(as % of merchandise exports) of 1963 in Singapore to that in Thailand?
Offer a very short reply. 0.66. What is the ratio of the Imports(as % of merchandise exports) of 1964 in Singapore to that in Thailand?
Give a very brief answer. 0.53. What is the ratio of the Imports(as % of merchandise exports) of 1965 in Singapore to that in Thailand?
Offer a very short reply. 0.64. What is the ratio of the Imports(as % of merchandise exports) of 1962 in Singapore to that in Turkey?
Offer a very short reply. 0.57. What is the ratio of the Imports(as % of merchandise exports) in 1963 in Singapore to that in Turkey?
Offer a terse response. 0.82. What is the ratio of the Imports(as % of merchandise exports) in 1964 in Singapore to that in Turkey?
Provide a succinct answer. 0.53. What is the ratio of the Imports(as % of merchandise exports) of 1965 in Singapore to that in Turkey?
Make the answer very short. 0.48. What is the ratio of the Imports(as % of merchandise exports) of 1962 in Spain to that in Sweden?
Keep it short and to the point. 1.13. What is the ratio of the Imports(as % of merchandise exports) in 1963 in Spain to that in Sweden?
Offer a terse response. 0.99. What is the ratio of the Imports(as % of merchandise exports) in 1964 in Spain to that in Sweden?
Ensure brevity in your answer.  1.06. What is the ratio of the Imports(as % of merchandise exports) in 1965 in Spain to that in Sweden?
Your response must be concise. 0.93. What is the ratio of the Imports(as % of merchandise exports) in 1962 in Spain to that in Switzerland?
Offer a terse response. 1.71. What is the ratio of the Imports(as % of merchandise exports) in 1963 in Spain to that in Switzerland?
Give a very brief answer. 1.57. What is the ratio of the Imports(as % of merchandise exports) of 1964 in Spain to that in Switzerland?
Keep it short and to the point. 1.73. What is the ratio of the Imports(as % of merchandise exports) in 1965 in Spain to that in Switzerland?
Keep it short and to the point. 1.62. What is the ratio of the Imports(as % of merchandise exports) of 1962 in Spain to that in Thailand?
Make the answer very short. 3.83. What is the ratio of the Imports(as % of merchandise exports) of 1963 in Spain to that in Thailand?
Provide a short and direct response. 3.01. What is the ratio of the Imports(as % of merchandise exports) of 1964 in Spain to that in Thailand?
Provide a succinct answer. 2.88. What is the ratio of the Imports(as % of merchandise exports) in 1965 in Spain to that in Thailand?
Ensure brevity in your answer.  3.19. What is the ratio of the Imports(as % of merchandise exports) in 1962 in Spain to that in Turkey?
Your answer should be very brief. 3.67. What is the ratio of the Imports(as % of merchandise exports) of 1963 in Spain to that in Turkey?
Make the answer very short. 3.74. What is the ratio of the Imports(as % of merchandise exports) in 1964 in Spain to that in Turkey?
Offer a terse response. 2.85. What is the ratio of the Imports(as % of merchandise exports) of 1965 in Spain to that in Turkey?
Your response must be concise. 2.42. What is the ratio of the Imports(as % of merchandise exports) in 1962 in Sweden to that in Switzerland?
Offer a terse response. 1.51. What is the ratio of the Imports(as % of merchandise exports) in 1963 in Sweden to that in Switzerland?
Your answer should be compact. 1.58. What is the ratio of the Imports(as % of merchandise exports) of 1964 in Sweden to that in Switzerland?
Provide a short and direct response. 1.63. What is the ratio of the Imports(as % of merchandise exports) in 1965 in Sweden to that in Switzerland?
Your answer should be very brief. 1.75. What is the ratio of the Imports(as % of merchandise exports) in 1962 in Sweden to that in Thailand?
Your answer should be compact. 3.39. What is the ratio of the Imports(as % of merchandise exports) in 1963 in Sweden to that in Thailand?
Provide a short and direct response. 3.03. What is the ratio of the Imports(as % of merchandise exports) of 1964 in Sweden to that in Thailand?
Make the answer very short. 2.72. What is the ratio of the Imports(as % of merchandise exports) in 1965 in Sweden to that in Thailand?
Offer a very short reply. 3.44. What is the ratio of the Imports(as % of merchandise exports) of 1962 in Sweden to that in Turkey?
Ensure brevity in your answer.  3.25. What is the ratio of the Imports(as % of merchandise exports) of 1963 in Sweden to that in Turkey?
Give a very brief answer. 3.76. What is the ratio of the Imports(as % of merchandise exports) of 1964 in Sweden to that in Turkey?
Provide a succinct answer. 2.69. What is the ratio of the Imports(as % of merchandise exports) in 1965 in Sweden to that in Turkey?
Your answer should be very brief. 2.61. What is the ratio of the Imports(as % of merchandise exports) of 1962 in Switzerland to that in Thailand?
Your answer should be compact. 2.24. What is the ratio of the Imports(as % of merchandise exports) in 1963 in Switzerland to that in Thailand?
Ensure brevity in your answer.  1.92. What is the ratio of the Imports(as % of merchandise exports) of 1964 in Switzerland to that in Thailand?
Your answer should be compact. 1.67. What is the ratio of the Imports(as % of merchandise exports) of 1965 in Switzerland to that in Thailand?
Offer a terse response. 1.96. What is the ratio of the Imports(as % of merchandise exports) of 1962 in Switzerland to that in Turkey?
Make the answer very short. 2.15. What is the ratio of the Imports(as % of merchandise exports) in 1963 in Switzerland to that in Turkey?
Keep it short and to the point. 2.38. What is the ratio of the Imports(as % of merchandise exports) of 1964 in Switzerland to that in Turkey?
Offer a terse response. 1.65. What is the ratio of the Imports(as % of merchandise exports) in 1965 in Switzerland to that in Turkey?
Offer a very short reply. 1.49. What is the ratio of the Imports(as % of merchandise exports) in 1962 in Thailand to that in Turkey?
Your response must be concise. 0.96. What is the ratio of the Imports(as % of merchandise exports) of 1963 in Thailand to that in Turkey?
Your response must be concise. 1.24. What is the ratio of the Imports(as % of merchandise exports) in 1964 in Thailand to that in Turkey?
Ensure brevity in your answer.  0.99. What is the ratio of the Imports(as % of merchandise exports) of 1965 in Thailand to that in Turkey?
Keep it short and to the point. 0.76. What is the difference between the highest and the second highest Imports(as % of merchandise exports) in 1962?
Your response must be concise. 0.74. What is the difference between the highest and the second highest Imports(as % of merchandise exports) in 1963?
Your response must be concise. 0.04. What is the difference between the highest and the second highest Imports(as % of merchandise exports) of 1964?
Your answer should be very brief. 0.36. What is the difference between the highest and the second highest Imports(as % of merchandise exports) of 1965?
Keep it short and to the point. 0.54. What is the difference between the highest and the lowest Imports(as % of merchandise exports) of 1962?
Give a very brief answer. 5.45. What is the difference between the highest and the lowest Imports(as % of merchandise exports) of 1963?
Your answer should be very brief. 4.32. What is the difference between the highest and the lowest Imports(as % of merchandise exports) of 1964?
Keep it short and to the point. 5.16. What is the difference between the highest and the lowest Imports(as % of merchandise exports) in 1965?
Your answer should be very brief. 5.96. 